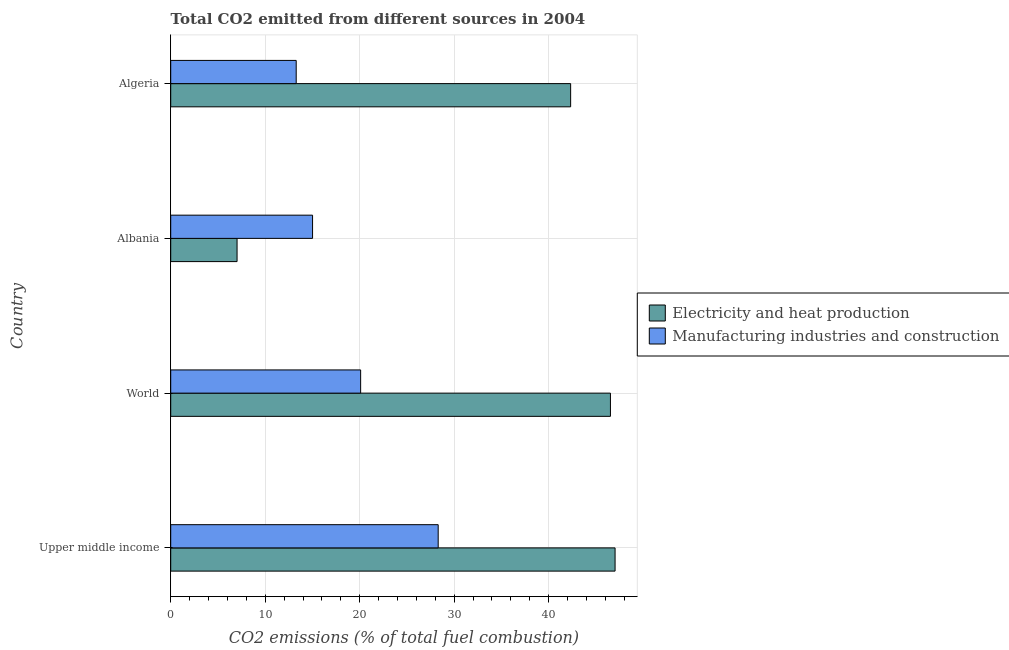What is the label of the 3rd group of bars from the top?
Make the answer very short. World. What is the co2 emissions due to electricity and heat production in World?
Your response must be concise. 46.54. Across all countries, what is the maximum co2 emissions due to electricity and heat production?
Your response must be concise. 47.03. Across all countries, what is the minimum co2 emissions due to manufacturing industries?
Provide a succinct answer. 13.28. In which country was the co2 emissions due to manufacturing industries maximum?
Offer a very short reply. Upper middle income. In which country was the co2 emissions due to manufacturing industries minimum?
Give a very brief answer. Algeria. What is the total co2 emissions due to electricity and heat production in the graph?
Ensure brevity in your answer.  142.91. What is the difference between the co2 emissions due to manufacturing industries in Upper middle income and that in World?
Offer a very short reply. 8.21. What is the difference between the co2 emissions due to manufacturing industries in Algeria and the co2 emissions due to electricity and heat production in Upper middle income?
Provide a short and direct response. -33.75. What is the average co2 emissions due to electricity and heat production per country?
Make the answer very short. 35.73. What is the difference between the co2 emissions due to manufacturing industries and co2 emissions due to electricity and heat production in Upper middle income?
Offer a very short reply. -18.72. What is the ratio of the co2 emissions due to electricity and heat production in Albania to that in World?
Keep it short and to the point. 0.15. Is the co2 emissions due to manufacturing industries in Albania less than that in World?
Provide a short and direct response. Yes. What is the difference between the highest and the second highest co2 emissions due to electricity and heat production?
Provide a succinct answer. 0.49. What is the difference between the highest and the lowest co2 emissions due to electricity and heat production?
Ensure brevity in your answer.  40. In how many countries, is the co2 emissions due to manufacturing industries greater than the average co2 emissions due to manufacturing industries taken over all countries?
Offer a terse response. 2. What does the 1st bar from the top in Upper middle income represents?
Your answer should be very brief. Manufacturing industries and construction. What does the 2nd bar from the bottom in Upper middle income represents?
Offer a very short reply. Manufacturing industries and construction. How many countries are there in the graph?
Offer a very short reply. 4. What is the difference between two consecutive major ticks on the X-axis?
Keep it short and to the point. 10. Are the values on the major ticks of X-axis written in scientific E-notation?
Offer a terse response. No. Where does the legend appear in the graph?
Your answer should be compact. Center right. How are the legend labels stacked?
Give a very brief answer. Vertical. What is the title of the graph?
Give a very brief answer. Total CO2 emitted from different sources in 2004. What is the label or title of the X-axis?
Provide a succinct answer. CO2 emissions (% of total fuel combustion). What is the CO2 emissions (% of total fuel combustion) of Electricity and heat production in Upper middle income?
Ensure brevity in your answer.  47.03. What is the CO2 emissions (% of total fuel combustion) in Manufacturing industries and construction in Upper middle income?
Provide a succinct answer. 28.31. What is the CO2 emissions (% of total fuel combustion) of Electricity and heat production in World?
Offer a very short reply. 46.54. What is the CO2 emissions (% of total fuel combustion) in Manufacturing industries and construction in World?
Your answer should be compact. 20.1. What is the CO2 emissions (% of total fuel combustion) in Electricity and heat production in Albania?
Offer a terse response. 7.02. What is the CO2 emissions (% of total fuel combustion) in Manufacturing industries and construction in Albania?
Keep it short and to the point. 15.01. What is the CO2 emissions (% of total fuel combustion) of Electricity and heat production in Algeria?
Ensure brevity in your answer.  42.32. What is the CO2 emissions (% of total fuel combustion) in Manufacturing industries and construction in Algeria?
Make the answer very short. 13.28. Across all countries, what is the maximum CO2 emissions (% of total fuel combustion) in Electricity and heat production?
Your response must be concise. 47.03. Across all countries, what is the maximum CO2 emissions (% of total fuel combustion) of Manufacturing industries and construction?
Your answer should be very brief. 28.31. Across all countries, what is the minimum CO2 emissions (% of total fuel combustion) in Electricity and heat production?
Offer a terse response. 7.02. Across all countries, what is the minimum CO2 emissions (% of total fuel combustion) of Manufacturing industries and construction?
Offer a terse response. 13.28. What is the total CO2 emissions (% of total fuel combustion) in Electricity and heat production in the graph?
Give a very brief answer. 142.91. What is the total CO2 emissions (% of total fuel combustion) in Manufacturing industries and construction in the graph?
Your answer should be compact. 76.7. What is the difference between the CO2 emissions (% of total fuel combustion) of Electricity and heat production in Upper middle income and that in World?
Offer a terse response. 0.49. What is the difference between the CO2 emissions (% of total fuel combustion) of Manufacturing industries and construction in Upper middle income and that in World?
Your answer should be very brief. 8.21. What is the difference between the CO2 emissions (% of total fuel combustion) of Electricity and heat production in Upper middle income and that in Albania?
Provide a short and direct response. 40. What is the difference between the CO2 emissions (% of total fuel combustion) of Manufacturing industries and construction in Upper middle income and that in Albania?
Your answer should be compact. 13.29. What is the difference between the CO2 emissions (% of total fuel combustion) of Electricity and heat production in Upper middle income and that in Algeria?
Provide a short and direct response. 4.7. What is the difference between the CO2 emissions (% of total fuel combustion) in Manufacturing industries and construction in Upper middle income and that in Algeria?
Your response must be concise. 15.03. What is the difference between the CO2 emissions (% of total fuel combustion) of Electricity and heat production in World and that in Albania?
Offer a terse response. 39.51. What is the difference between the CO2 emissions (% of total fuel combustion) in Manufacturing industries and construction in World and that in Albania?
Make the answer very short. 5.09. What is the difference between the CO2 emissions (% of total fuel combustion) in Electricity and heat production in World and that in Algeria?
Provide a short and direct response. 4.21. What is the difference between the CO2 emissions (% of total fuel combustion) of Manufacturing industries and construction in World and that in Algeria?
Your answer should be very brief. 6.82. What is the difference between the CO2 emissions (% of total fuel combustion) of Electricity and heat production in Albania and that in Algeria?
Keep it short and to the point. -35.3. What is the difference between the CO2 emissions (% of total fuel combustion) of Manufacturing industries and construction in Albania and that in Algeria?
Your answer should be compact. 1.73. What is the difference between the CO2 emissions (% of total fuel combustion) of Electricity and heat production in Upper middle income and the CO2 emissions (% of total fuel combustion) of Manufacturing industries and construction in World?
Give a very brief answer. 26.93. What is the difference between the CO2 emissions (% of total fuel combustion) of Electricity and heat production in Upper middle income and the CO2 emissions (% of total fuel combustion) of Manufacturing industries and construction in Albania?
Your answer should be very brief. 32.01. What is the difference between the CO2 emissions (% of total fuel combustion) of Electricity and heat production in Upper middle income and the CO2 emissions (% of total fuel combustion) of Manufacturing industries and construction in Algeria?
Ensure brevity in your answer.  33.75. What is the difference between the CO2 emissions (% of total fuel combustion) of Electricity and heat production in World and the CO2 emissions (% of total fuel combustion) of Manufacturing industries and construction in Albania?
Keep it short and to the point. 31.52. What is the difference between the CO2 emissions (% of total fuel combustion) in Electricity and heat production in World and the CO2 emissions (% of total fuel combustion) in Manufacturing industries and construction in Algeria?
Offer a terse response. 33.26. What is the difference between the CO2 emissions (% of total fuel combustion) of Electricity and heat production in Albania and the CO2 emissions (% of total fuel combustion) of Manufacturing industries and construction in Algeria?
Your answer should be compact. -6.26. What is the average CO2 emissions (% of total fuel combustion) of Electricity and heat production per country?
Provide a succinct answer. 35.73. What is the average CO2 emissions (% of total fuel combustion) of Manufacturing industries and construction per country?
Provide a succinct answer. 19.17. What is the difference between the CO2 emissions (% of total fuel combustion) in Electricity and heat production and CO2 emissions (% of total fuel combustion) in Manufacturing industries and construction in Upper middle income?
Your answer should be compact. 18.72. What is the difference between the CO2 emissions (% of total fuel combustion) of Electricity and heat production and CO2 emissions (% of total fuel combustion) of Manufacturing industries and construction in World?
Provide a short and direct response. 26.44. What is the difference between the CO2 emissions (% of total fuel combustion) of Electricity and heat production and CO2 emissions (% of total fuel combustion) of Manufacturing industries and construction in Albania?
Your response must be concise. -7.99. What is the difference between the CO2 emissions (% of total fuel combustion) of Electricity and heat production and CO2 emissions (% of total fuel combustion) of Manufacturing industries and construction in Algeria?
Keep it short and to the point. 29.04. What is the ratio of the CO2 emissions (% of total fuel combustion) of Electricity and heat production in Upper middle income to that in World?
Give a very brief answer. 1.01. What is the ratio of the CO2 emissions (% of total fuel combustion) in Manufacturing industries and construction in Upper middle income to that in World?
Give a very brief answer. 1.41. What is the ratio of the CO2 emissions (% of total fuel combustion) of Electricity and heat production in Upper middle income to that in Albania?
Provide a succinct answer. 6.7. What is the ratio of the CO2 emissions (% of total fuel combustion) of Manufacturing industries and construction in Upper middle income to that in Albania?
Ensure brevity in your answer.  1.89. What is the ratio of the CO2 emissions (% of total fuel combustion) of Electricity and heat production in Upper middle income to that in Algeria?
Keep it short and to the point. 1.11. What is the ratio of the CO2 emissions (% of total fuel combustion) in Manufacturing industries and construction in Upper middle income to that in Algeria?
Ensure brevity in your answer.  2.13. What is the ratio of the CO2 emissions (% of total fuel combustion) in Electricity and heat production in World to that in Albania?
Give a very brief answer. 6.63. What is the ratio of the CO2 emissions (% of total fuel combustion) in Manufacturing industries and construction in World to that in Albania?
Provide a succinct answer. 1.34. What is the ratio of the CO2 emissions (% of total fuel combustion) in Electricity and heat production in World to that in Algeria?
Give a very brief answer. 1.1. What is the ratio of the CO2 emissions (% of total fuel combustion) in Manufacturing industries and construction in World to that in Algeria?
Keep it short and to the point. 1.51. What is the ratio of the CO2 emissions (% of total fuel combustion) in Electricity and heat production in Albania to that in Algeria?
Make the answer very short. 0.17. What is the ratio of the CO2 emissions (% of total fuel combustion) in Manufacturing industries and construction in Albania to that in Algeria?
Make the answer very short. 1.13. What is the difference between the highest and the second highest CO2 emissions (% of total fuel combustion) in Electricity and heat production?
Make the answer very short. 0.49. What is the difference between the highest and the second highest CO2 emissions (% of total fuel combustion) of Manufacturing industries and construction?
Make the answer very short. 8.21. What is the difference between the highest and the lowest CO2 emissions (% of total fuel combustion) in Electricity and heat production?
Provide a short and direct response. 40. What is the difference between the highest and the lowest CO2 emissions (% of total fuel combustion) of Manufacturing industries and construction?
Make the answer very short. 15.03. 